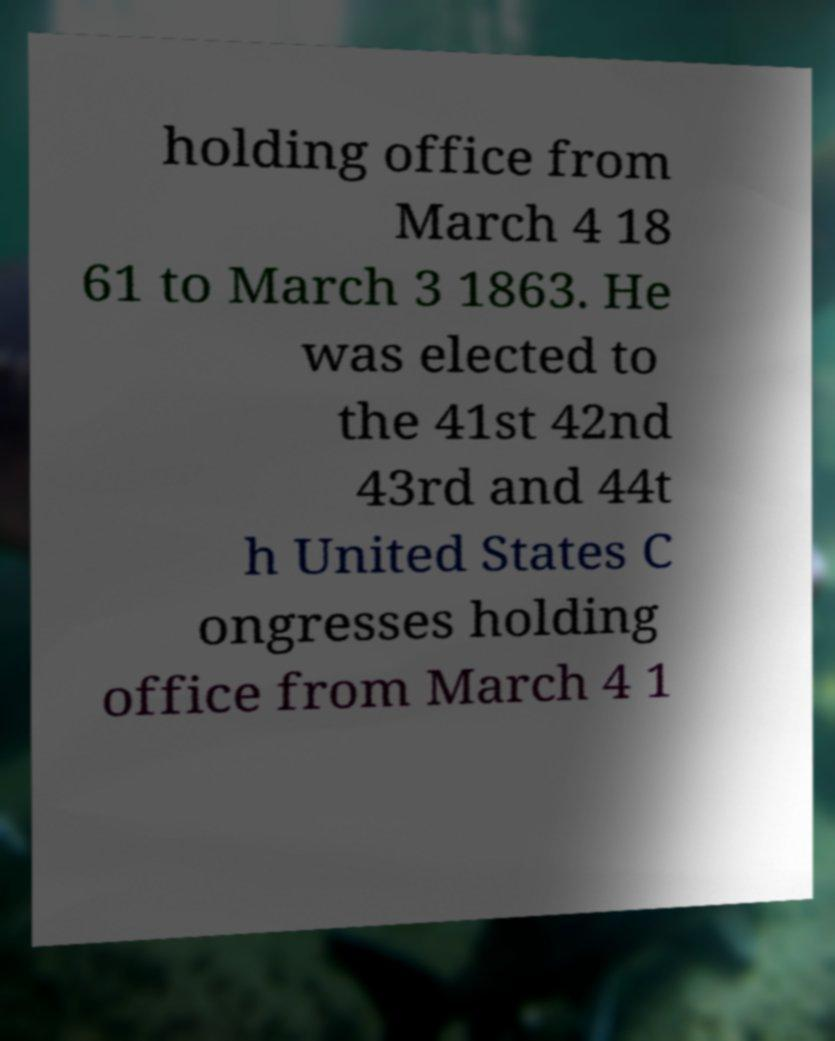Can you read and provide the text displayed in the image?This photo seems to have some interesting text. Can you extract and type it out for me? holding office from March 4 18 61 to March 3 1863. He was elected to the 41st 42nd 43rd and 44t h United States C ongresses holding office from March 4 1 